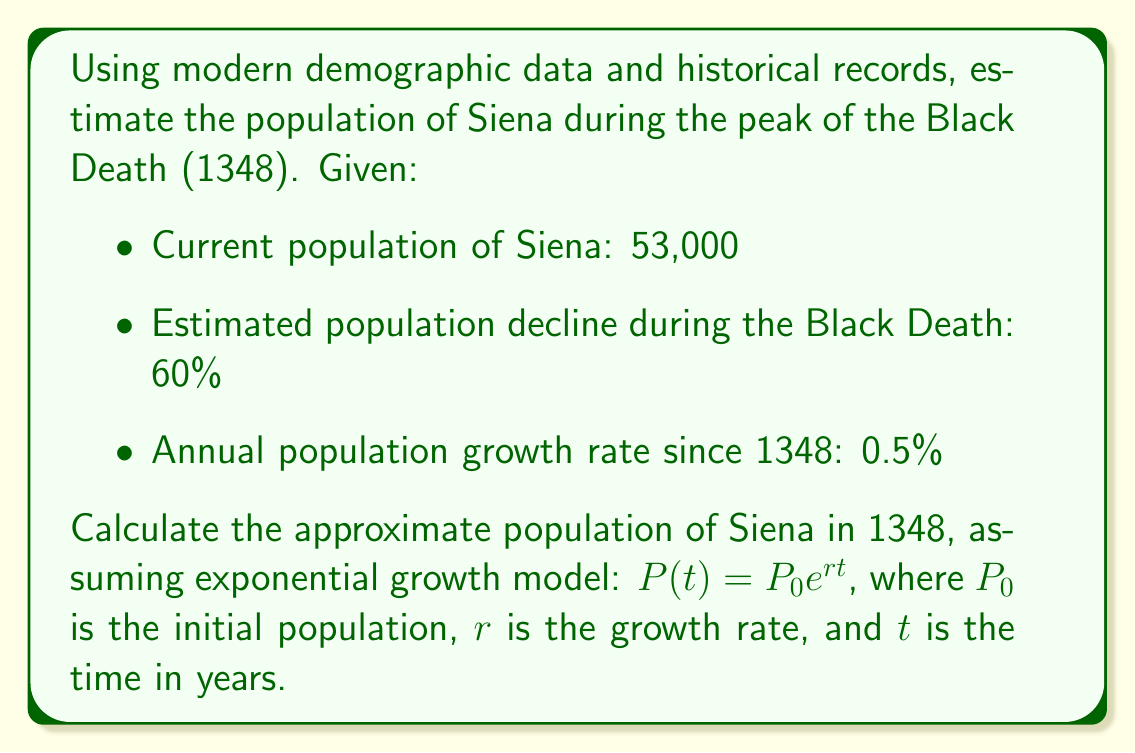Can you answer this question? To solve this inverse problem, we'll work backwards from the current population:

1. Set up the exponential growth equation:
   $53,000 = P_0 e^{0.005t}$, where $t = 2023 - 1348 = 675$ years

2. Substitute the values:
   $53,000 = P_0 e^{0.005 \cdot 675}$

3. Simplify the exponent:
   $53,000 = P_0 e^{3.375}$

4. Solve for $P_0$:
   $P_0 = 53,000 / e^{3.375} \approx 1,834$

5. This $P_0$ represents the population after the Black Death. To find the population before the pandemic, we need to account for the 60% decline:
   $1,834 = x - 0.6x$, where $x$ is the original population
   $1,834 = 0.4x$

6. Solve for $x$:
   $x = 1,834 / 0.4 = 4,585$

Therefore, the estimated population of Siena in 1348, at the peak of the Black Death, was approximately 4,585 people.
Answer: 4,585 people 